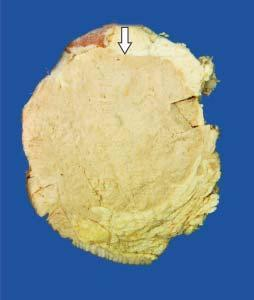what shows a large grey white soft fleshy tumour replacing almost whole of the breast?
Answer the question using a single word or phrase. Cut surface of the breast 